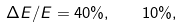Convert formula to latex. <formula><loc_0><loc_0><loc_500><loc_500>\Delta E / E = 4 0 \% , \quad 1 0 \% ,</formula> 